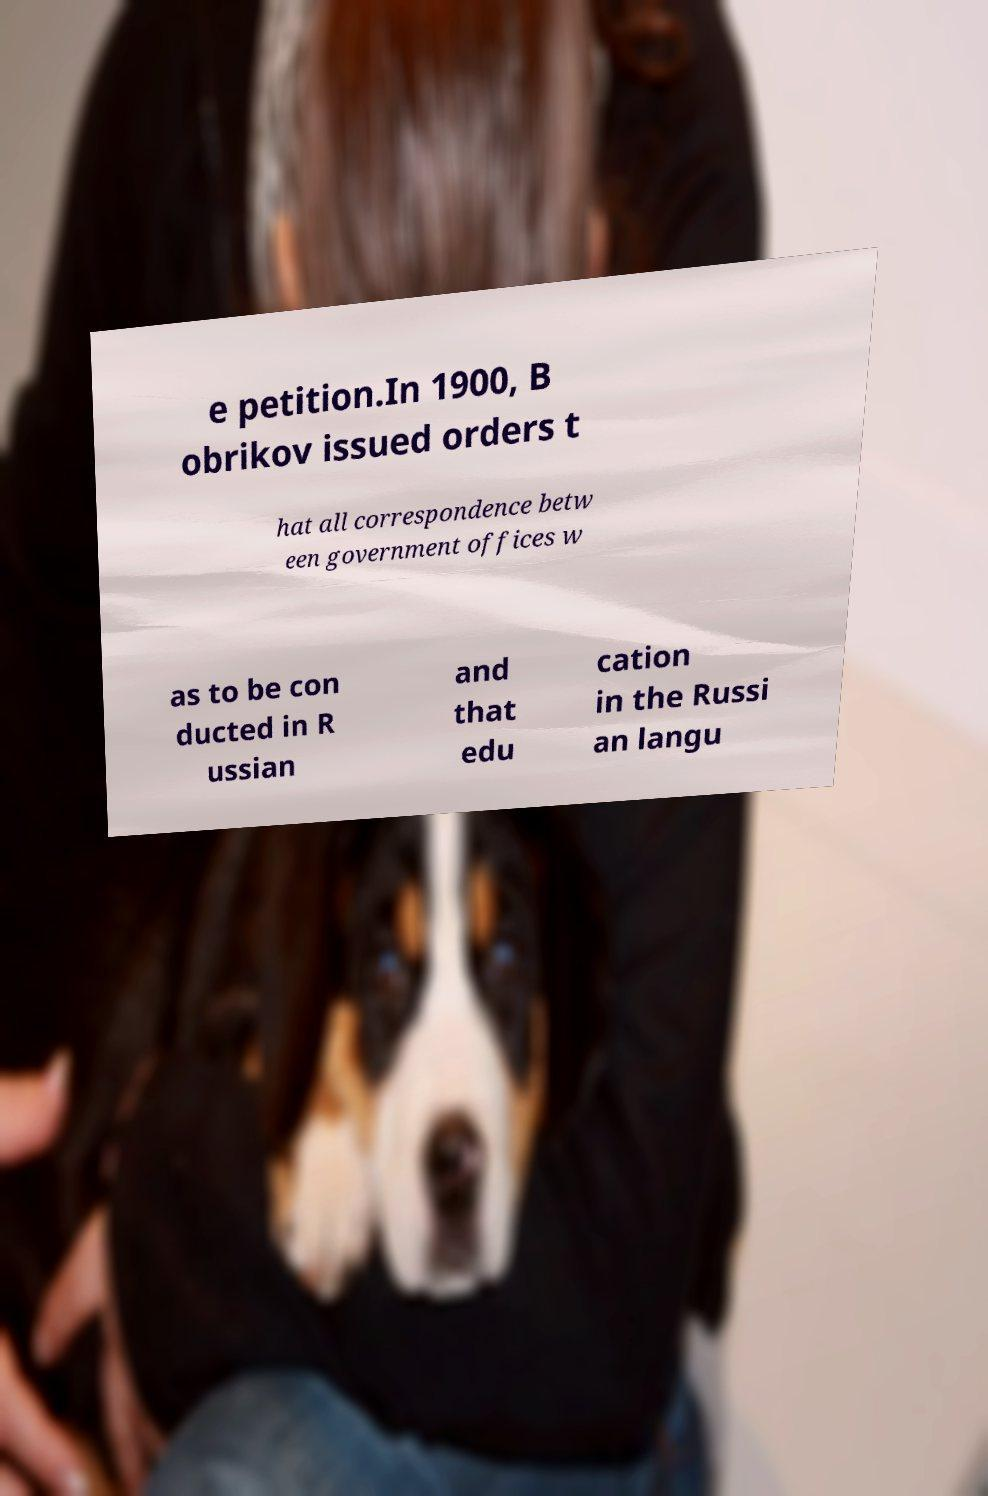Please read and relay the text visible in this image. What does it say? e petition.In 1900, B obrikov issued orders t hat all correspondence betw een government offices w as to be con ducted in R ussian and that edu cation in the Russi an langu 